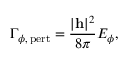Convert formula to latex. <formula><loc_0><loc_0><loc_500><loc_500>\Gamma _ { \phi , \, p e r t } = \frac { | { h } | ^ { 2 } } { 8 \pi } E _ { \phi } ,</formula> 